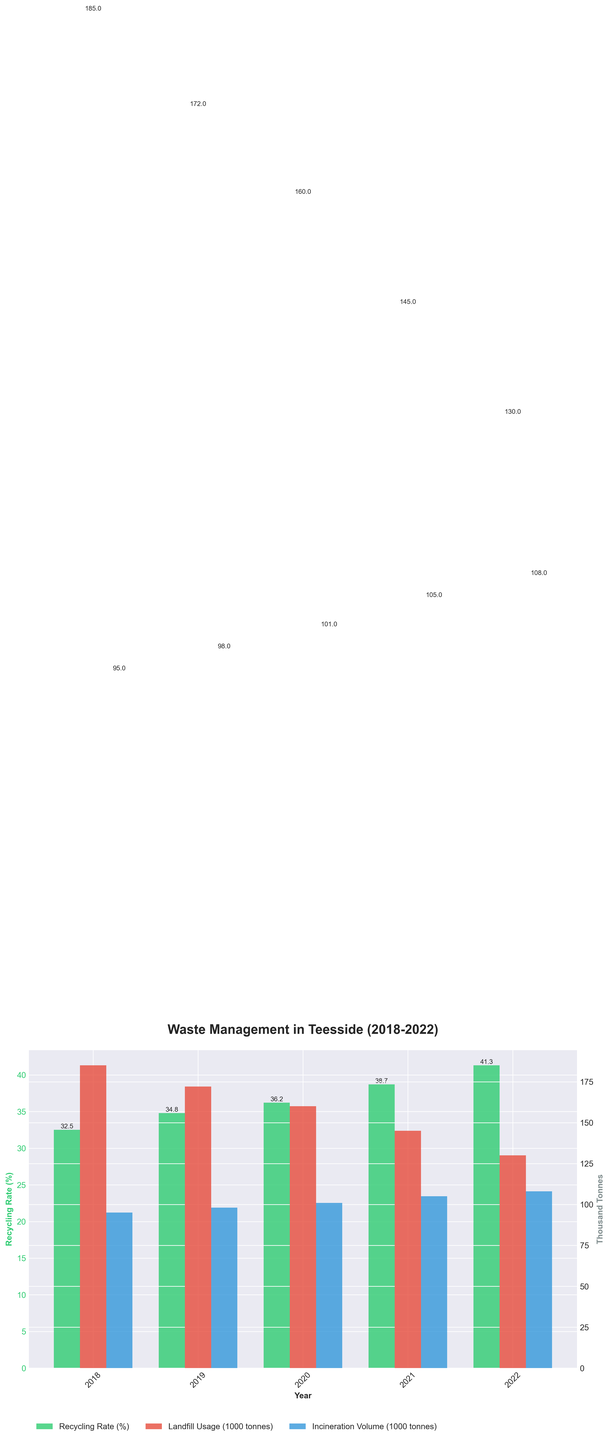What is the trend in the recycling rate from 2018 to 2022? To identify the trend, look at the heights of the green bars representing the recycling rate for each year. They consistently increase from 32.5% in 2018 to 41.3% in 2022.
Answer: The recycling rate is increasing Which year had the highest landfill usage, and what was the value? Compare the heights of the red bars that represent landfill usage for each year. The tallest red bar corresponds to 2018, indicating the highest landfill usage, which is 185,000 tonnes (185 when converted to thousands).
Answer: 2018, 185,000 tonnes What is the difference in the recycling rate between 2018 and 2022? Subtract the recycling rate of 2018 (32.5%) from that of 2022 (41.3%). The difference is 41.3% - 32.5% = 8.8%.
Answer: 8.8% In which year did incineration volumes exceed 100,000 tonnes for the first time? Look for the first instance where the blue bar representing incineration volume surpasses the 100 (thousand tonnes) mark on the y-axis. This occurs in 2020, with 101,000 tonnes.
Answer: 2020 What is the combined total of landfill usage and incineration volume in 2021? Add the landfill usage (145,000 tonnes) and incineration volume (105,000 tonnes) for 2021. The total is 145,000 + 105,000 = 250,000 tonnes.
Answer: 250,000 tonnes How does the incineration volume in 2022 compare to that in 2018? Compare the heights of the blue bars for 2018 and 2022. The incineration volume increased from 95,000 tonnes in 2018 to 108,000 tonnes in 2022.
Answer: 2022 is higher by 13,000 tonnes What is the average recycling rate over the five years shown? Add the recycling rates for all years and divide by the number of years. (32.5% + 34.8% + 36.2% + 38.7% + 41.3%) / 5 = 36.7%.
Answer: 36.7% Which year had the lowest incineration volume, and what was the value? Locate the shortest blue bar, which represents incineration volume. This occurs in 2018, with 95,000 tonnes.
Answer: 2018, 95,000 tonnes What can be inferred about waste management trends in Teesside from 2018 to 2022? Observing the figure, you can infer that the recycling rate has been steadily increasing while both landfill usage and incineration volumes have fluctuating trends, with landfill usage generally decreasing and incineration volumes increasing slightly.
Answer: Increasing recycling rate, decreasing landfill, increasing incineration 